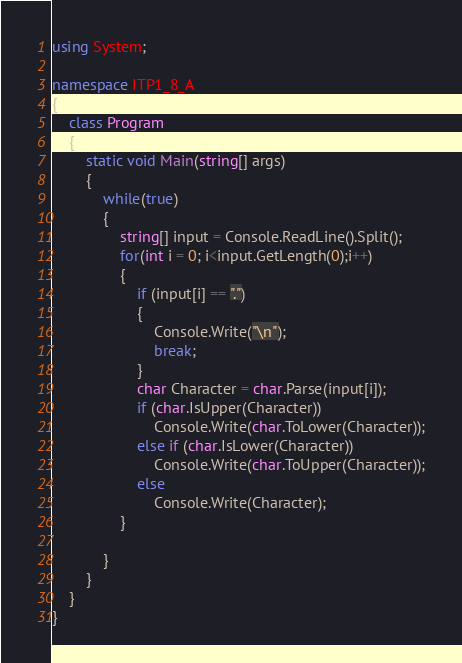<code> <loc_0><loc_0><loc_500><loc_500><_C#_>using System;

namespace ITP1_8_A
{
    class Program
    {
        static void Main(string[] args)
        {
            while(true)
            {
                string[] input = Console.ReadLine().Split();
                for(int i = 0; i<input.GetLength(0);i++)
                {
                    if (input[i] == ".")
                    {
                        Console.Write("\n");
                        break;
                    }
                    char Character = char.Parse(input[i]);
                    if (char.IsUpper(Character))
                        Console.Write(char.ToLower(Character));
                    else if (char.IsLower(Character))
                        Console.Write(char.ToUpper(Character));
                    else
                        Console.Write(Character);
                }

            }
        }
    }
}</code> 